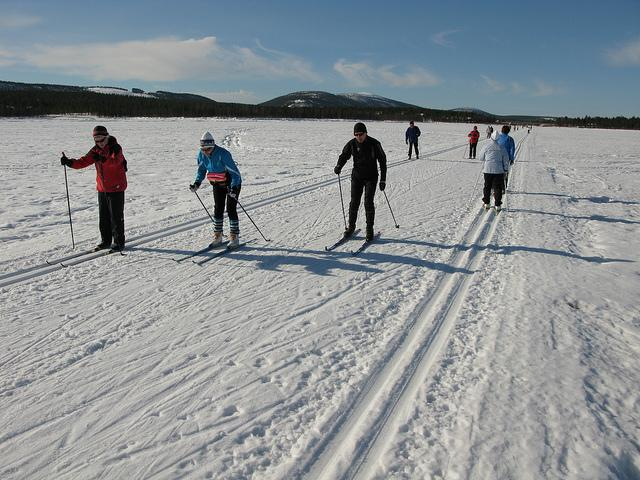What is the location of the sun in the image? left 